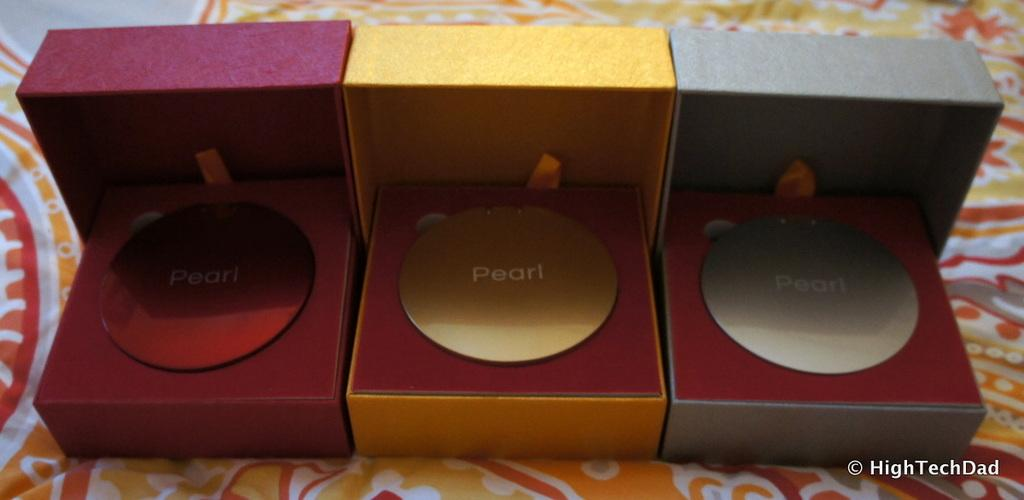<image>
Offer a succinct explanation of the picture presented. Three small boxes each contain a disc with Pearl written on it. 